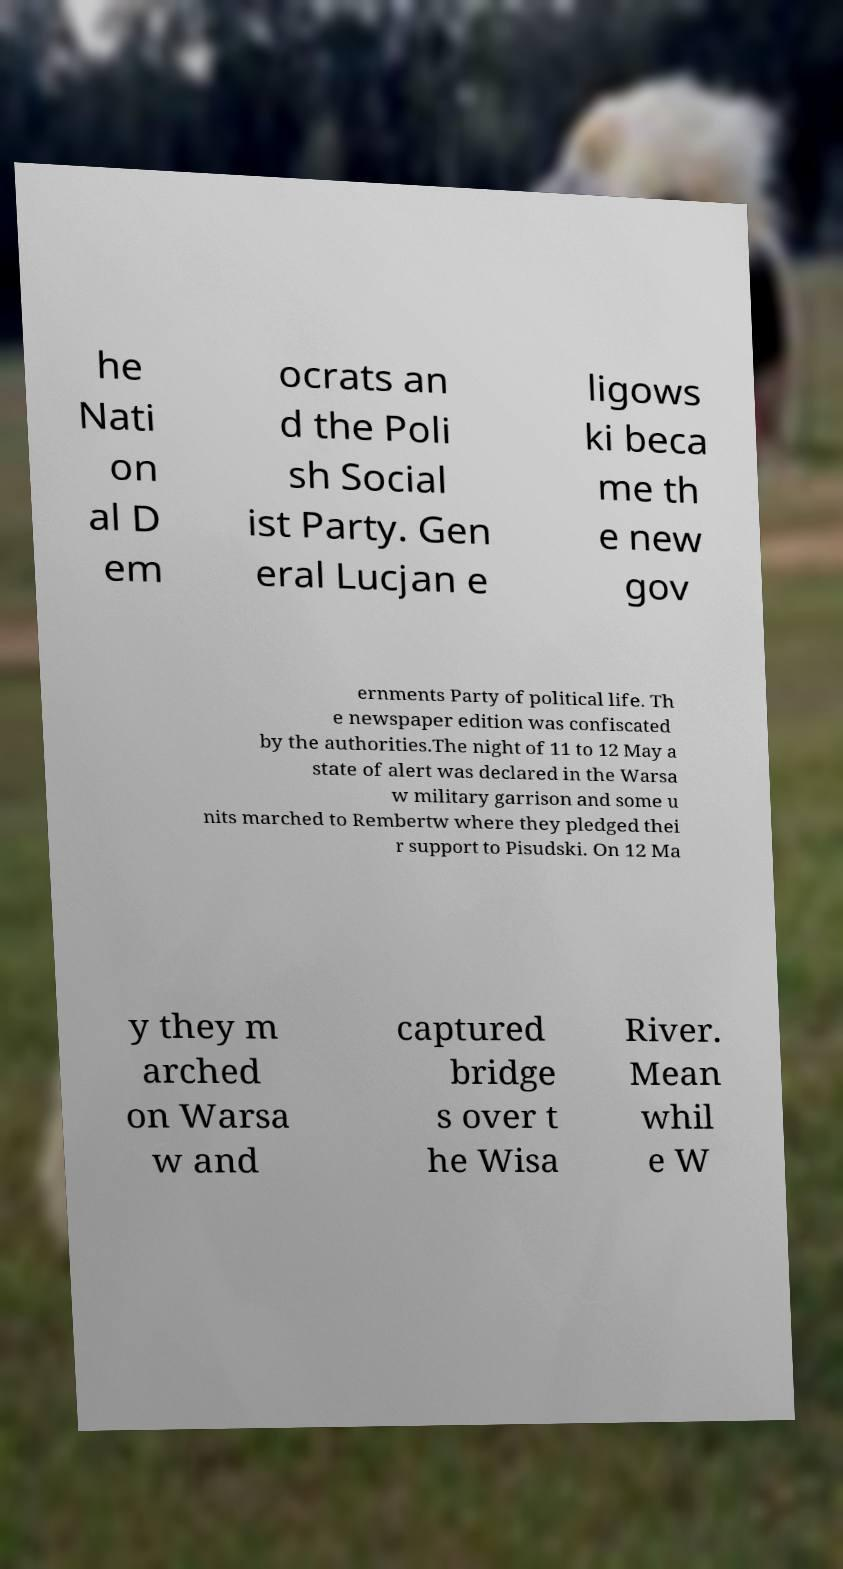There's text embedded in this image that I need extracted. Can you transcribe it verbatim? he Nati on al D em ocrats an d the Poli sh Social ist Party. Gen eral Lucjan e ligows ki beca me th e new gov ernments Party of political life. Th e newspaper edition was confiscated by the authorities.The night of 11 to 12 May a state of alert was declared in the Warsa w military garrison and some u nits marched to Rembertw where they pledged thei r support to Pisudski. On 12 Ma y they m arched on Warsa w and captured bridge s over t he Wisa River. Mean whil e W 